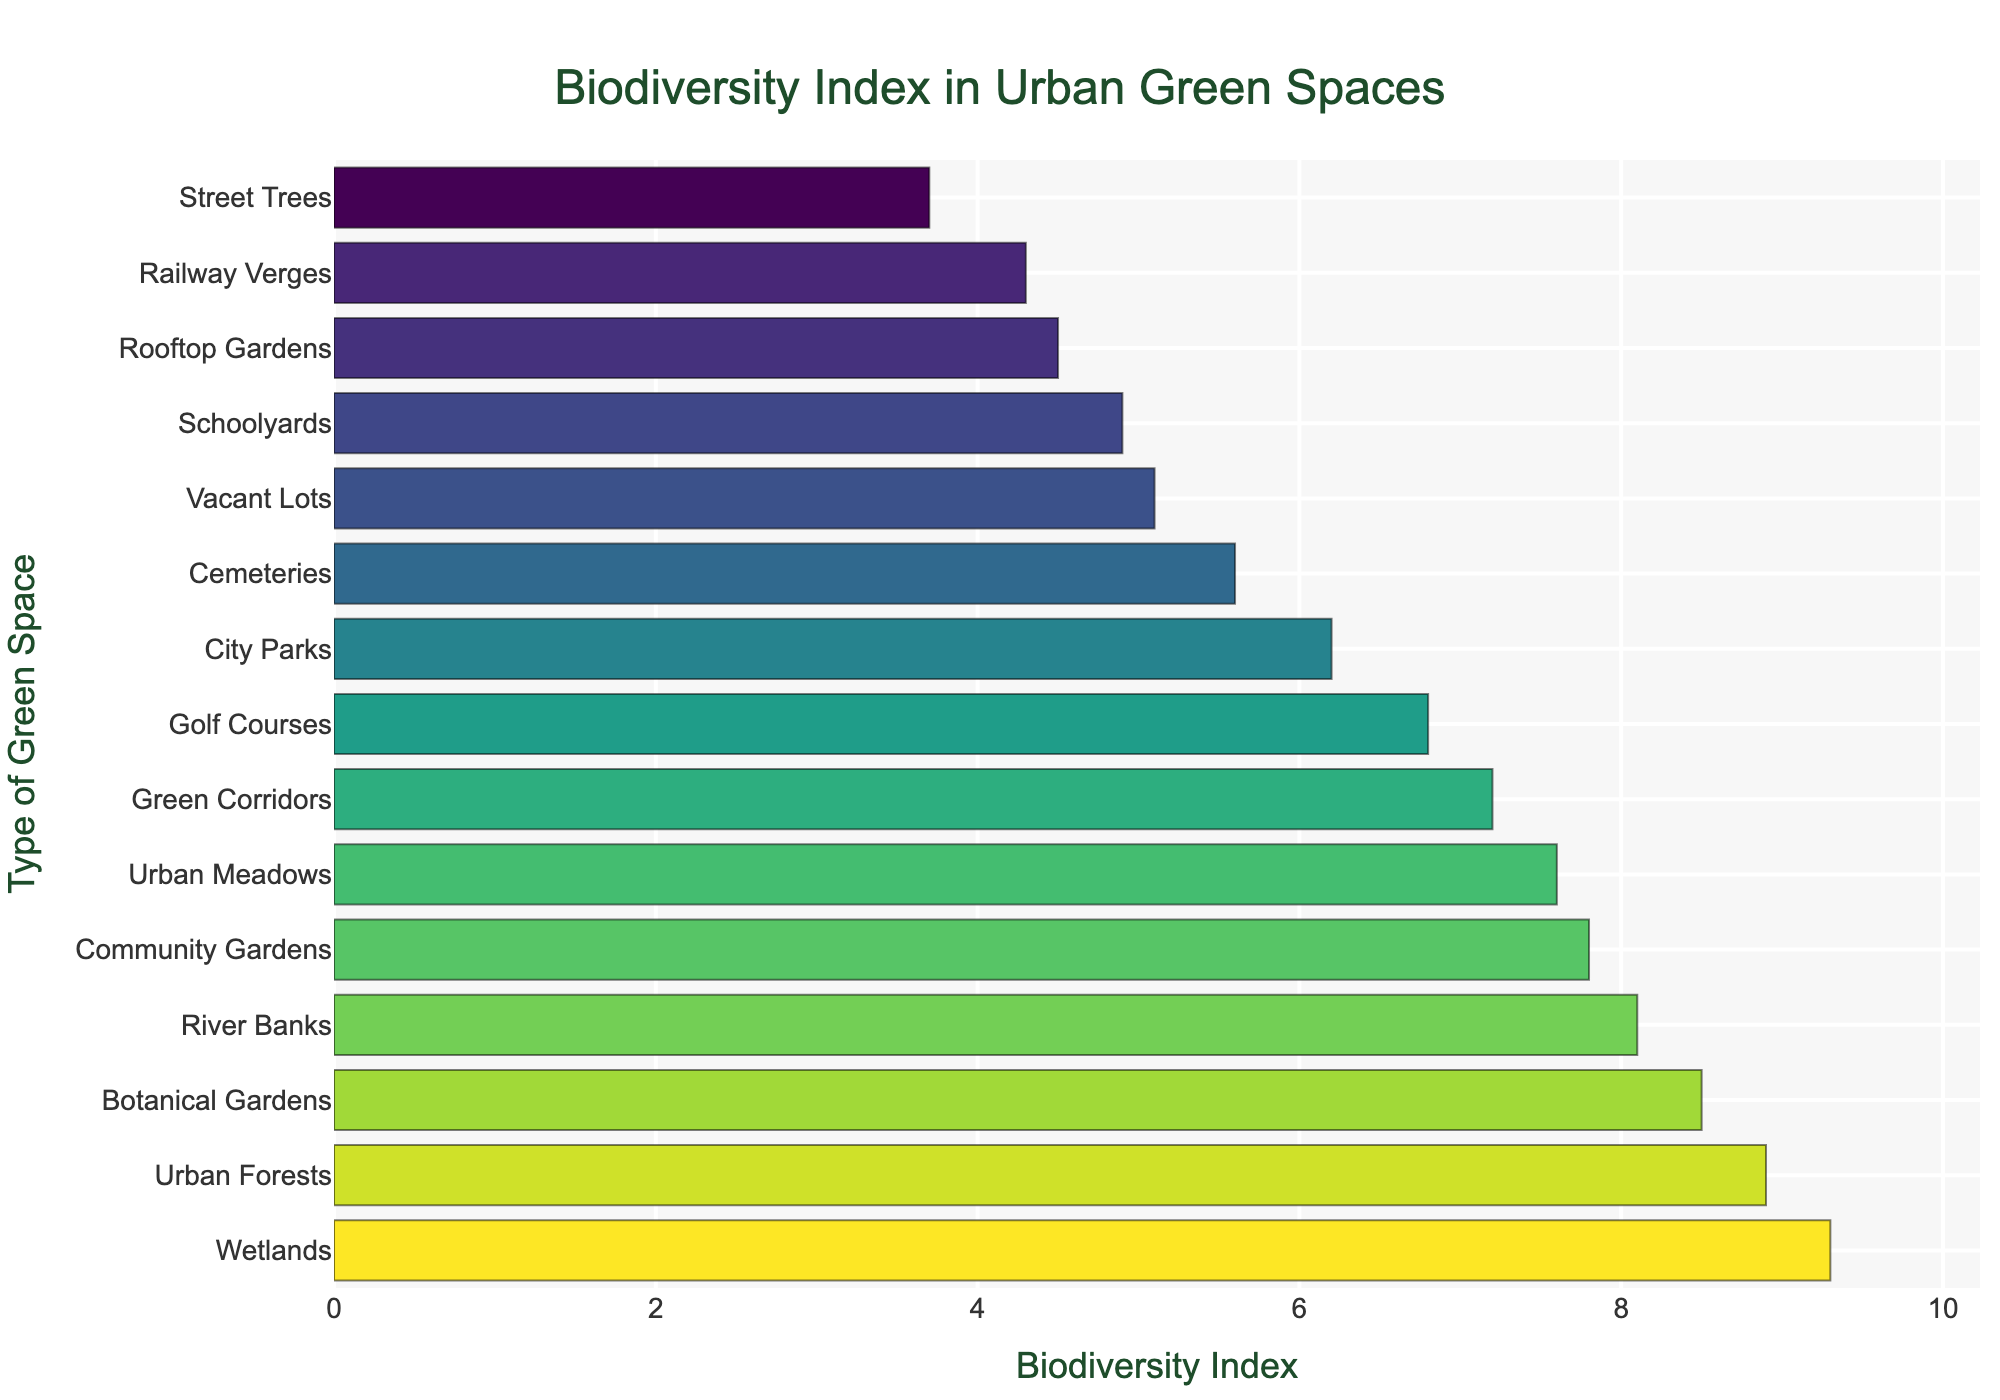What's the highest Biodiversity Index among the urban green spaces? Look at the bar that is the longest (to the rightmost) in the figure. The top value is taken from the label and the figure's scale.
Answer: 9.3 Which type of green space has the lowest Biodiversity Index? Look for the shortest bar (to the leftmost) and note the green space type from the y-axis label.
Answer: Street Trees What is the Biodiversity Index difference between Wetlands and Urban Forests? Identify the Biodiversity Index for Wetlands (9.3) and Urban Forests (8.9) from the length of the bars and subtract the smaller value from the larger one. The difference is 9.3 - 8.9 = 0.4.
Answer: 0.4 What is the average Biodiversity Index of Community Gardens, Schoolyards, and Golf Courses? Identify the Biodiversity Index values for Community Gardens (7.8), Schoolyards (4.9), and Golf Courses (6.8). Sum these values (7.8 + 4.9 + 6.8) = 19.5, then divide by the number of values (3). The average is 19.5 / 3 = 6.5.
Answer: 6.5 Are there more green spaces with a Biodiversity Index above 8.0 or below 5.0? Count the number of bars taller than 8.0: Wetlands, Urban Forests, Botanical Gardens, River Banks (4). Count the bars shorter than 5.0: Street Trees, Railway Verges, Rooftop Gardens (3). Compare the counts: 4 (above 8.0) vs. 3 (below 5.0).
Answer: Above 8.0 What is the total Biodiversity Index for all green spaces combined? Add all Biodiversity Index values from the bars: 6.2 + 7.8 + 4.5 + 8.9 + 9.3 + 5.1 + 3.7 + 8.5 + 7.2 + 4.9 + 5.6 + 6.8 + 8.1 + 4.3 + 7.6. The total is 98.5.
Answer: 98.5 Which two green spaces have the closest Biodiversity Index values and what are those values? Look at pairs of bars with similar lengths. Find Urban Meadows (7.6) and Community Gardens (7.8). The values are close and indeed they differ by 0.2.
Answer: Urban Meadows and Community Gardens: 7.6 and 7.8 